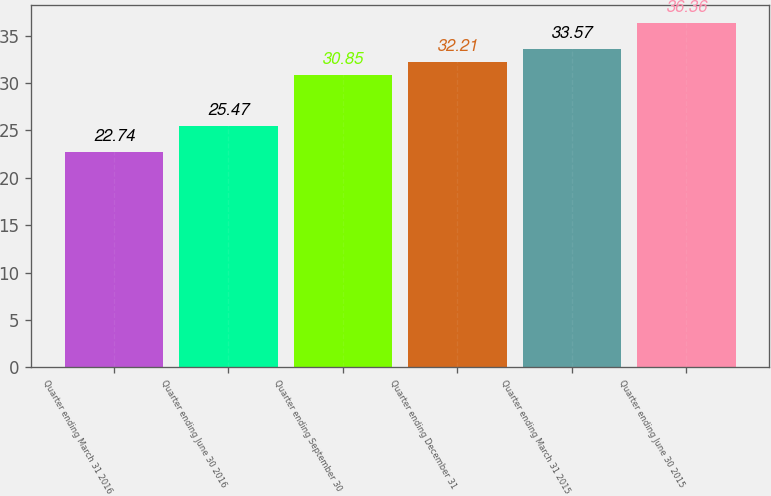Convert chart. <chart><loc_0><loc_0><loc_500><loc_500><bar_chart><fcel>Quarter ending March 31 2016<fcel>Quarter ending June 30 2016<fcel>Quarter ending September 30<fcel>Quarter ending December 31<fcel>Quarter ending March 31 2015<fcel>Quarter ending June 30 2015<nl><fcel>22.74<fcel>25.47<fcel>30.85<fcel>32.21<fcel>33.57<fcel>36.36<nl></chart> 